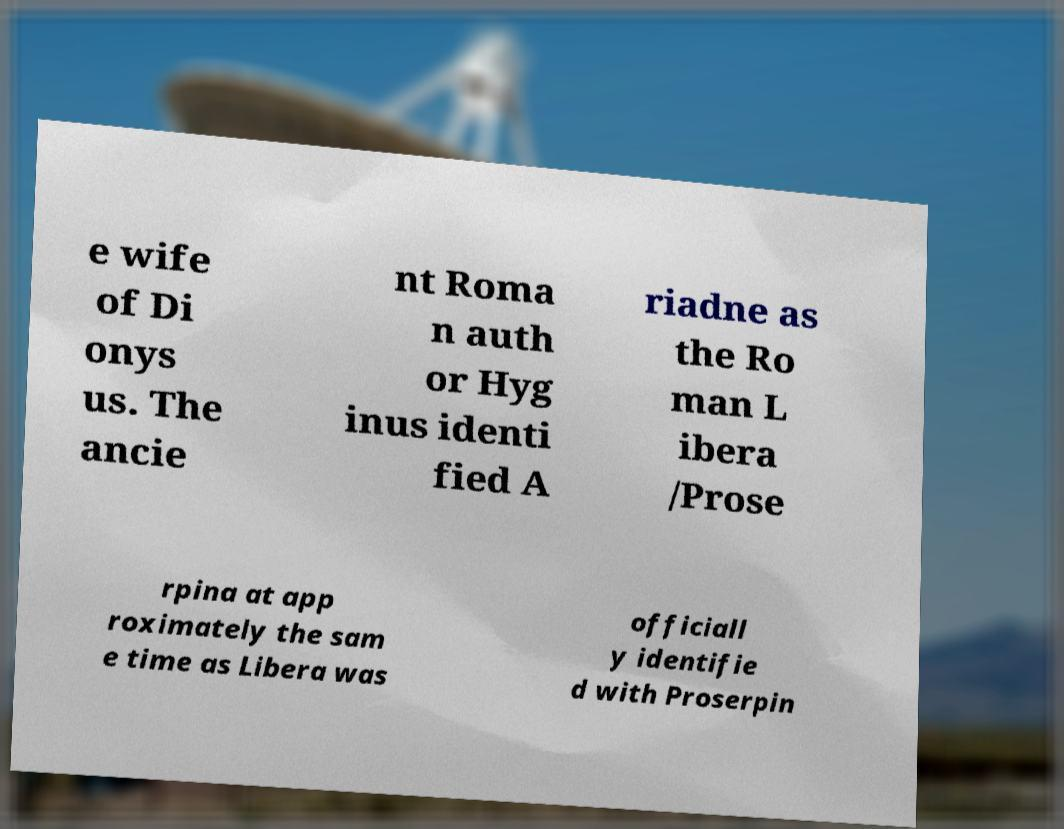Please read and relay the text visible in this image. What does it say? e wife of Di onys us. The ancie nt Roma n auth or Hyg inus identi fied A riadne as the Ro man L ibera /Prose rpina at app roximately the sam e time as Libera was officiall y identifie d with Proserpin 